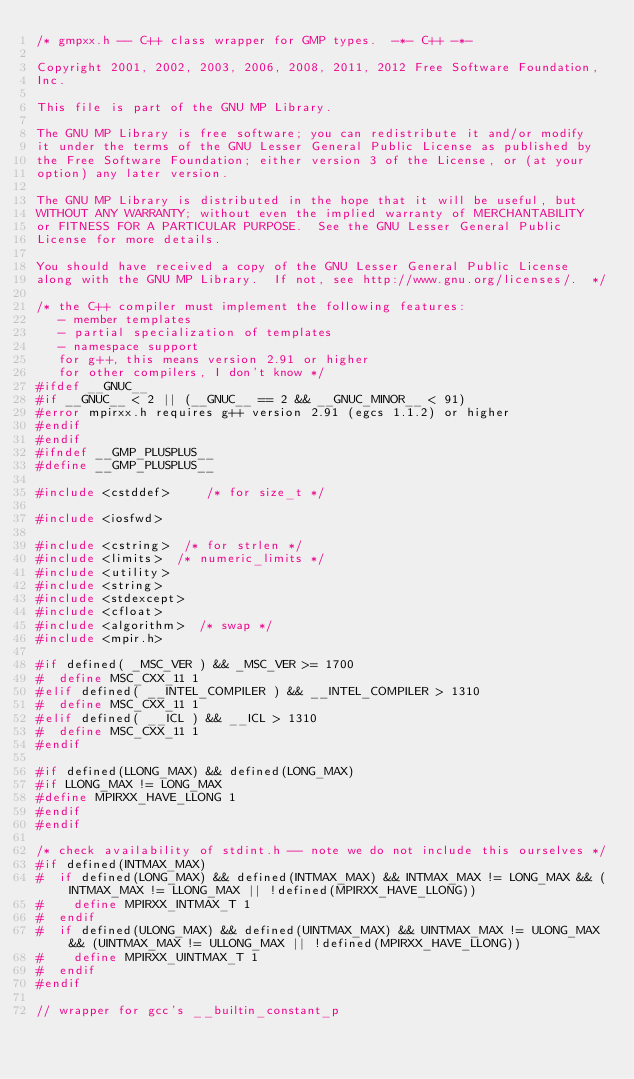<code> <loc_0><loc_0><loc_500><loc_500><_C_>/* gmpxx.h -- C++ class wrapper for GMP types.  -*- C++ -*-

Copyright 2001, 2002, 2003, 2006, 2008, 2011, 2012 Free Software Foundation,
Inc.

This file is part of the GNU MP Library.

The GNU MP Library is free software; you can redistribute it and/or modify
it under the terms of the GNU Lesser General Public License as published by
the Free Software Foundation; either version 3 of the License, or (at your
option) any later version.

The GNU MP Library is distributed in the hope that it will be useful, but
WITHOUT ANY WARRANTY; without even the implied warranty of MERCHANTABILITY
or FITNESS FOR A PARTICULAR PURPOSE.  See the GNU Lesser General Public
License for more details.

You should have received a copy of the GNU Lesser General Public License
along with the GNU MP Library.  If not, see http://www.gnu.org/licenses/.  */

/* the C++ compiler must implement the following features:
   - member templates
   - partial specialization of templates
   - namespace support
   for g++, this means version 2.91 or higher
   for other compilers, I don't know */
#ifdef __GNUC__
#if __GNUC__ < 2 || (__GNUC__ == 2 && __GNUC_MINOR__ < 91)
#error mpirxx.h requires g++ version 2.91 (egcs 1.1.2) or higher
#endif
#endif
#ifndef __GMP_PLUSPLUS__
#define __GMP_PLUSPLUS__

#include <cstddef>     /* for size_t */

#include <iosfwd>

#include <cstring>  /* for strlen */
#include <limits>  /* numeric_limits */
#include <utility>
#include <string>
#include <stdexcept>
#include <cfloat>
#include <algorithm>  /* swap */
#include <mpir.h>

#if defined( _MSC_VER ) && _MSC_VER >= 1700
#  define MSC_CXX_11 1
#elif defined( __INTEL_COMPILER ) && __INTEL_COMPILER > 1310
#  define MSC_CXX_11 1
#elif defined( __ICL ) && __ICL > 1310
#  define MSC_CXX_11 1
#endif

#if defined(LLONG_MAX) && defined(LONG_MAX)
#if LLONG_MAX != LONG_MAX
#define MPIRXX_HAVE_LLONG 1
#endif
#endif

/* check availability of stdint.h -- note we do not include this ourselves */
#if defined(INTMAX_MAX)
#  if defined(LONG_MAX) && defined(INTMAX_MAX) && INTMAX_MAX != LONG_MAX && (INTMAX_MAX != LLONG_MAX || !defined(MPIRXX_HAVE_LLONG))
#    define MPIRXX_INTMAX_T 1
#  endif
#  if defined(ULONG_MAX) && defined(UINTMAX_MAX) && UINTMAX_MAX != ULONG_MAX && (UINTMAX_MAX != ULLONG_MAX || !defined(MPIRXX_HAVE_LLONG))
#    define MPIRXX_UINTMAX_T 1
#  endif
#endif

// wrapper for gcc's __builtin_constant_p</code> 